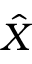<formula> <loc_0><loc_0><loc_500><loc_500>\hat { X }</formula> 